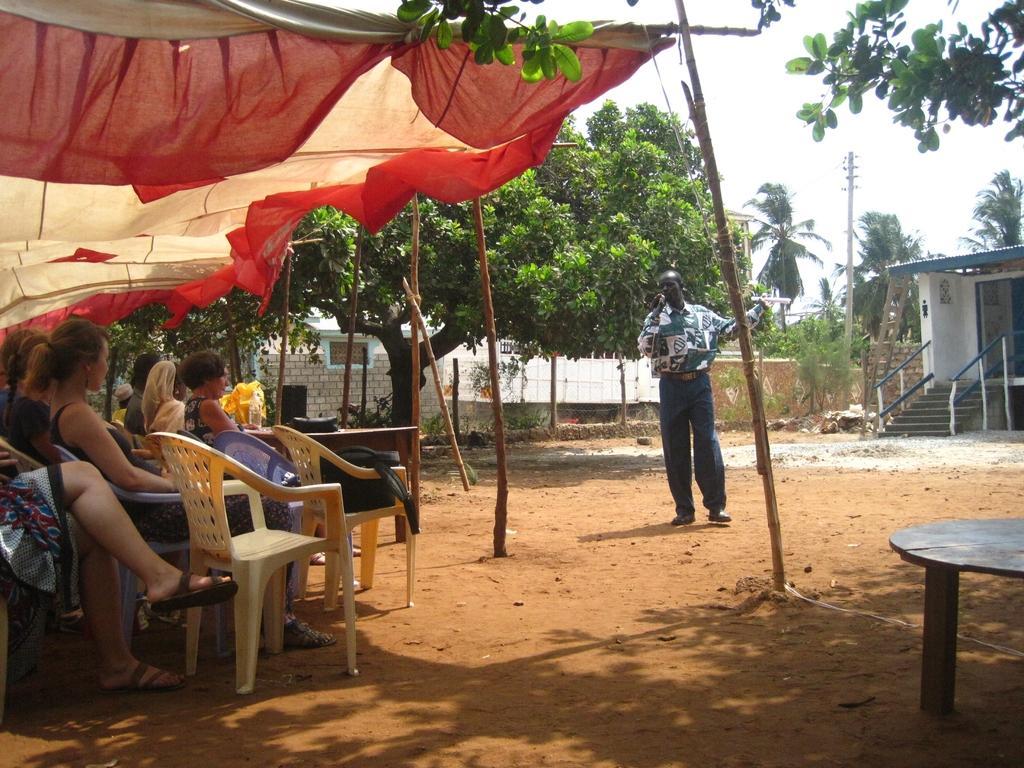Please provide a concise description of this image. In this image there are group of people those who are sitting on the chairs under a tent and there is a person who is standing at the center of the image and there is a mic in his hand, it seems he is explaining something and there are some trees around the area of the image and there is a building at the left side of the image, it is observed at the right side of the image there are stairs. 